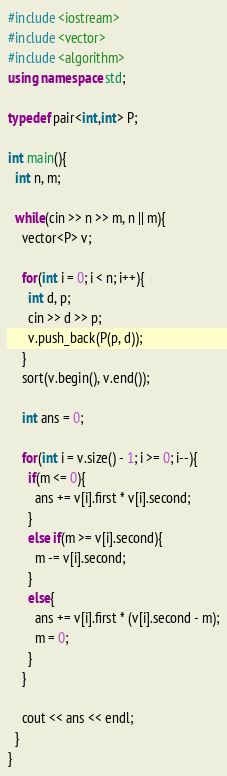Convert code to text. <code><loc_0><loc_0><loc_500><loc_500><_C++_>#include <iostream>
#include <vector>
#include <algorithm>
using namespace std;

typedef pair<int,int> P;

int main(){
  int n, m;

  while(cin >> n >> m, n || m){
    vector<P> v;

    for(int i = 0; i < n; i++){
      int d, p;
      cin >> d >> p;
      v.push_back(P(p, d));
    }
    sort(v.begin(), v.end());

    int ans = 0;

    for(int i = v.size() - 1; i >= 0; i--){
      if(m <= 0){
        ans += v[i].first * v[i].second;
      }
      else if(m >= v[i].second){
        m -= v[i].second;
      }
      else{
        ans += v[i].first * (v[i].second - m);
        m = 0;
      }
    }

    cout << ans << endl;
  }
}</code> 